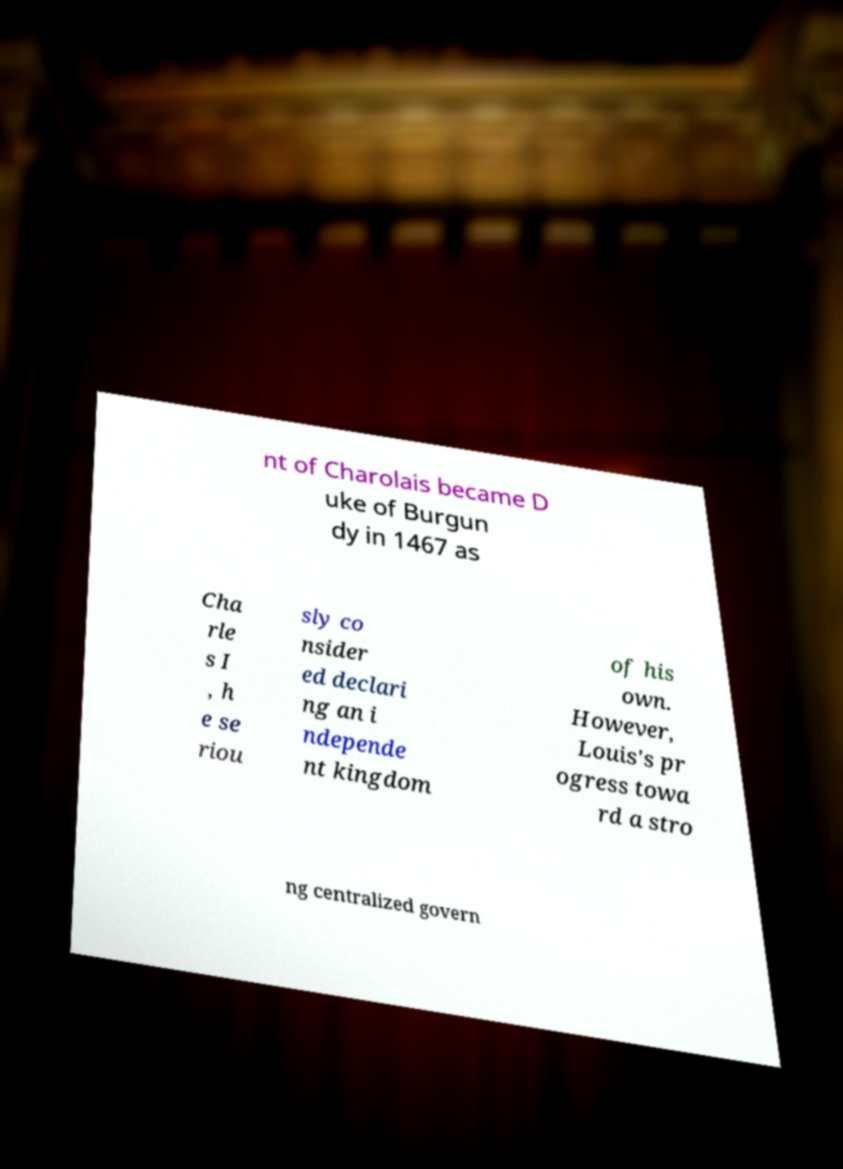Can you read and provide the text displayed in the image?This photo seems to have some interesting text. Can you extract and type it out for me? nt of Charolais became D uke of Burgun dy in 1467 as Cha rle s I , h e se riou sly co nsider ed declari ng an i ndepende nt kingdom of his own. However, Louis's pr ogress towa rd a stro ng centralized govern 